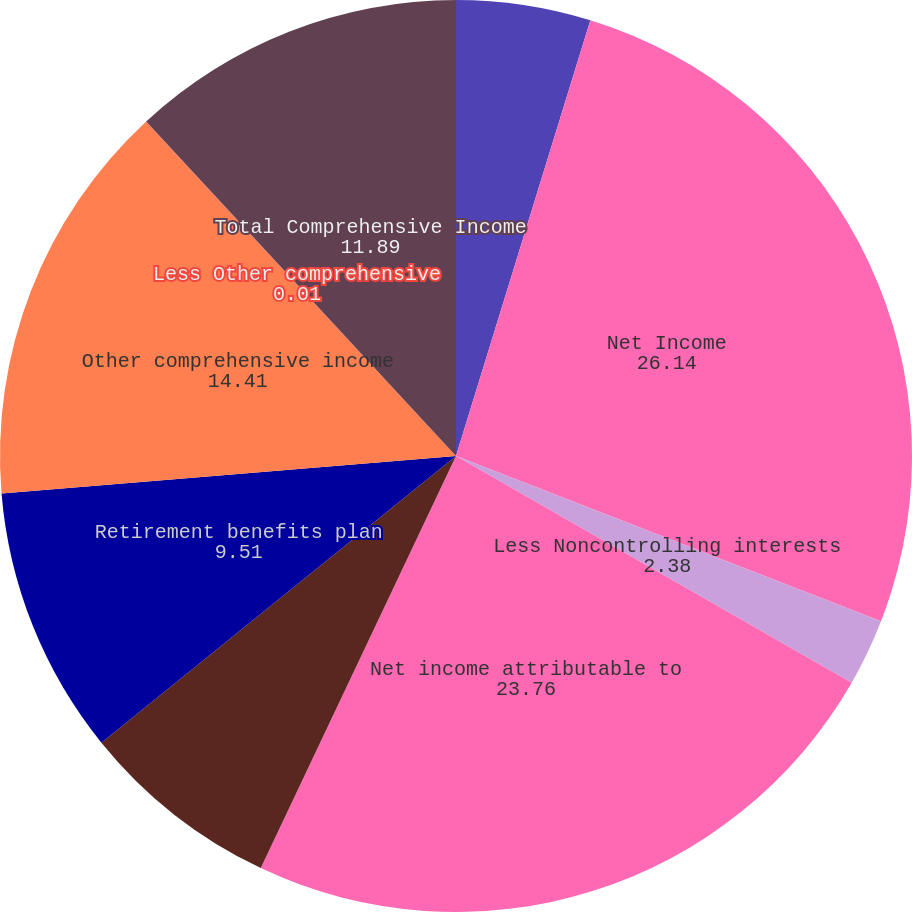Convert chart to OTSL. <chart><loc_0><loc_0><loc_500><loc_500><pie_chart><fcel>(Dollars in thousands)<fcel>Net Income<fcel>Less Noncontrolling interests<fcel>Net income attributable to<fcel>Foreign currency translation<fcel>Retirement benefits plan<fcel>Other comprehensive income<fcel>Less Other comprehensive<fcel>Total Comprehensive Income<nl><fcel>4.76%<fcel>26.14%<fcel>2.38%<fcel>23.76%<fcel>7.14%<fcel>9.51%<fcel>14.41%<fcel>0.01%<fcel>11.89%<nl></chart> 